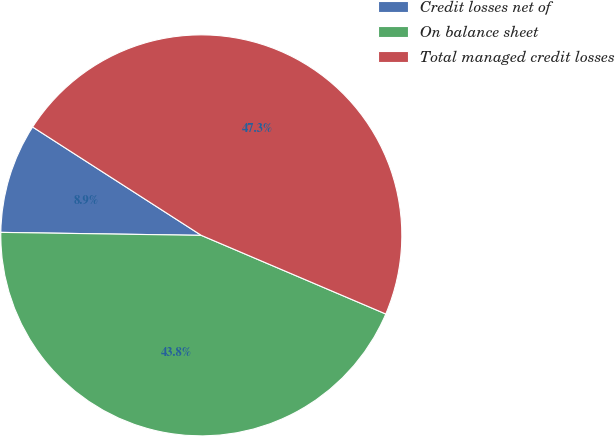<chart> <loc_0><loc_0><loc_500><loc_500><pie_chart><fcel>Credit losses net of<fcel>On balance sheet<fcel>Total managed credit losses<nl><fcel>8.85%<fcel>43.82%<fcel>47.32%<nl></chart> 